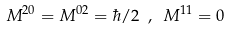Convert formula to latex. <formula><loc_0><loc_0><loc_500><loc_500>M ^ { 2 0 } = M ^ { 0 2 } = \hbar { / } 2 \ , \ M ^ { 1 1 } = 0</formula> 